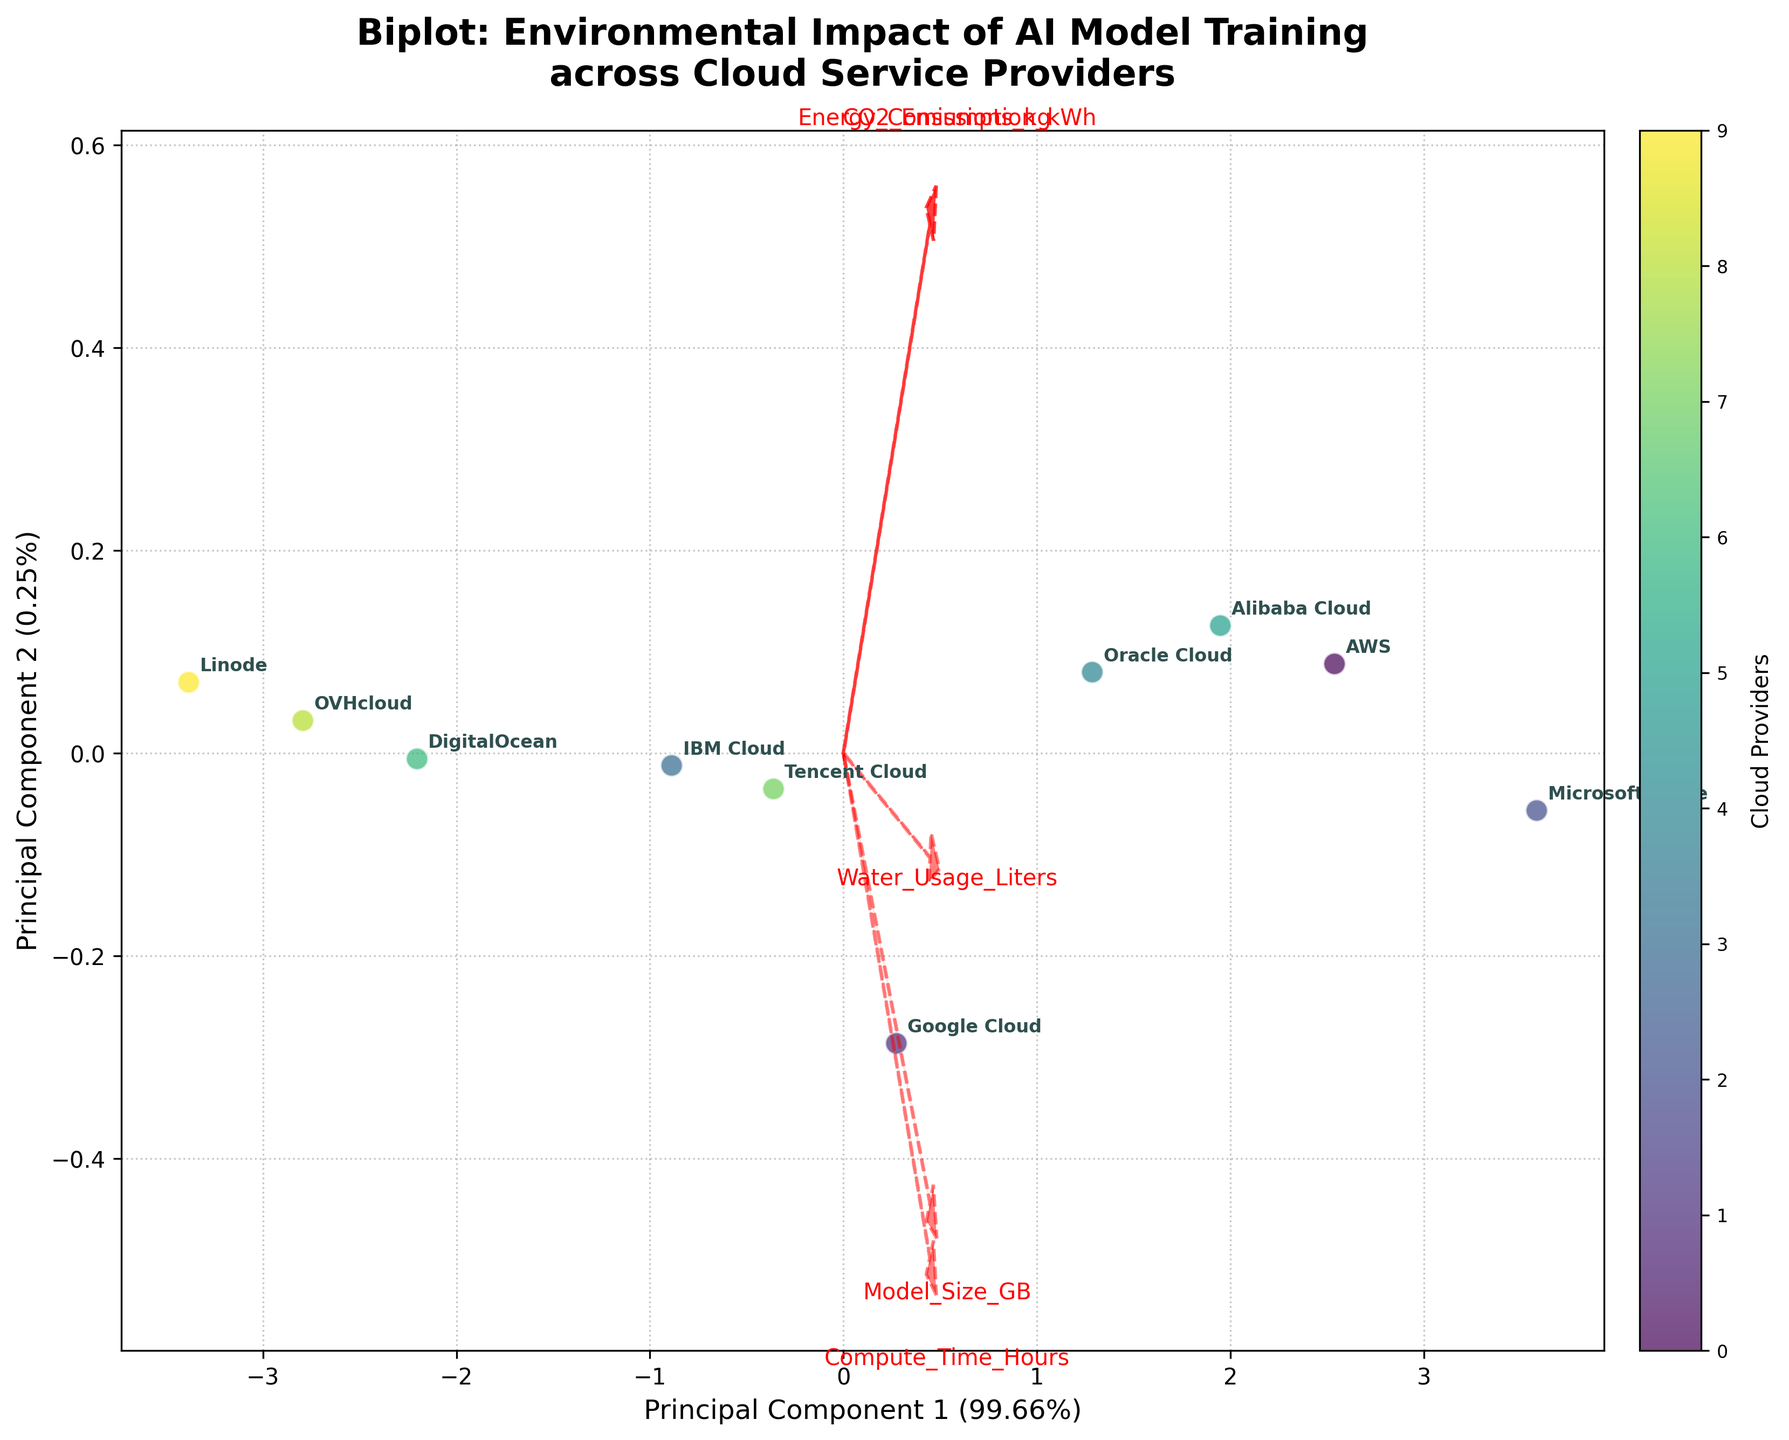What is the title of the figure? The title is typically displayed at the top center of a plot, summarizing the visualized information. Here, it includes the general topic of the plot which is the environmental impact of AI model training across different cloud service providers, indicating it is a biplot.
Answer: Biplot: Environmental Impact of AI Model Training across Cloud Service Providers How many principal components are shown on the biplot? A biplot usually shows the number of principal components based on the axes labels. In this case, we can see the labels for Principal Component 1 and Principal Component 2 on the x-axis and y-axis, respectively, indicating two principal components.
Answer: Two Which cloud provider appears closest to the origin of the biplot? The origin of a biplot is the point (0,0). The cloud provider closest to this point will have its label nearest to this center.
Answer: Linode What does the arrow labeled "CO2_Emissions_kg" represent? Arrows in a biplot represent the original variables projected into the principal component space. The length and direction indicate the correlation of the variable with the principal components. "CO2_Emissions_kg" arrow shows how CO2 emissions are correlated with the principal components.
Answer: The correlation of CO2 emissions with the principal components Which cloud provider is represented by the point farthest to the right? To determine the cloud provider farthest to the right, we look at the x-axis of the biplot and identify the cloud provider label that is positioned at the extreme right.
Answer: Microsoft Azure How much variance is explained by Principal Component 1? The explained variance ratio of a principal component is usually indicated in parentheses next to the axis label. Here, Principal Component 1’s axis label contains this information.
Answer: Varies, typically displayed in the plot Which cloud providers have similar environmental impact profiles according to the biplot? Cloud providers close to each other in the biplot space have similar profiles in terms of the variables analyzed. We can identify clusters of providers that are positioned near each other.
Answer: IBM Cloud and Google Cloud (example, may vary in actual plot) 